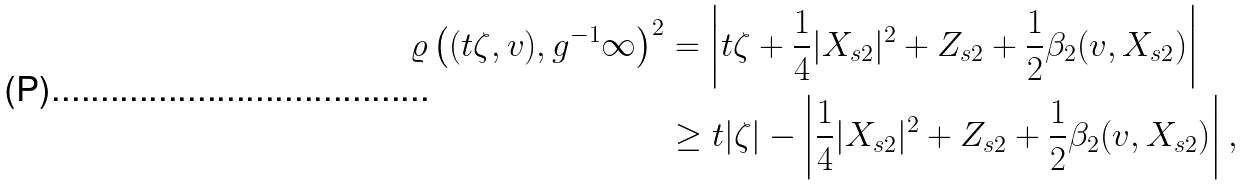<formula> <loc_0><loc_0><loc_500><loc_500>\varrho \left ( ( t \zeta , v ) , g ^ { - 1 } \infty \right ) ^ { 2 } & = \left | t \zeta + \frac { 1 } { 4 } | X _ { s 2 } | ^ { 2 } + Z _ { s 2 } + \frac { 1 } { 2 } \beta _ { 2 } ( v , X _ { s 2 } ) \right | \\ & \geq t | \zeta | - \left | \frac { 1 } { 4 } | X _ { s 2 } | ^ { 2 } + Z _ { s 2 } + \frac { 1 } { 2 } \beta _ { 2 } ( v , X _ { s 2 } ) \right | ,</formula> 